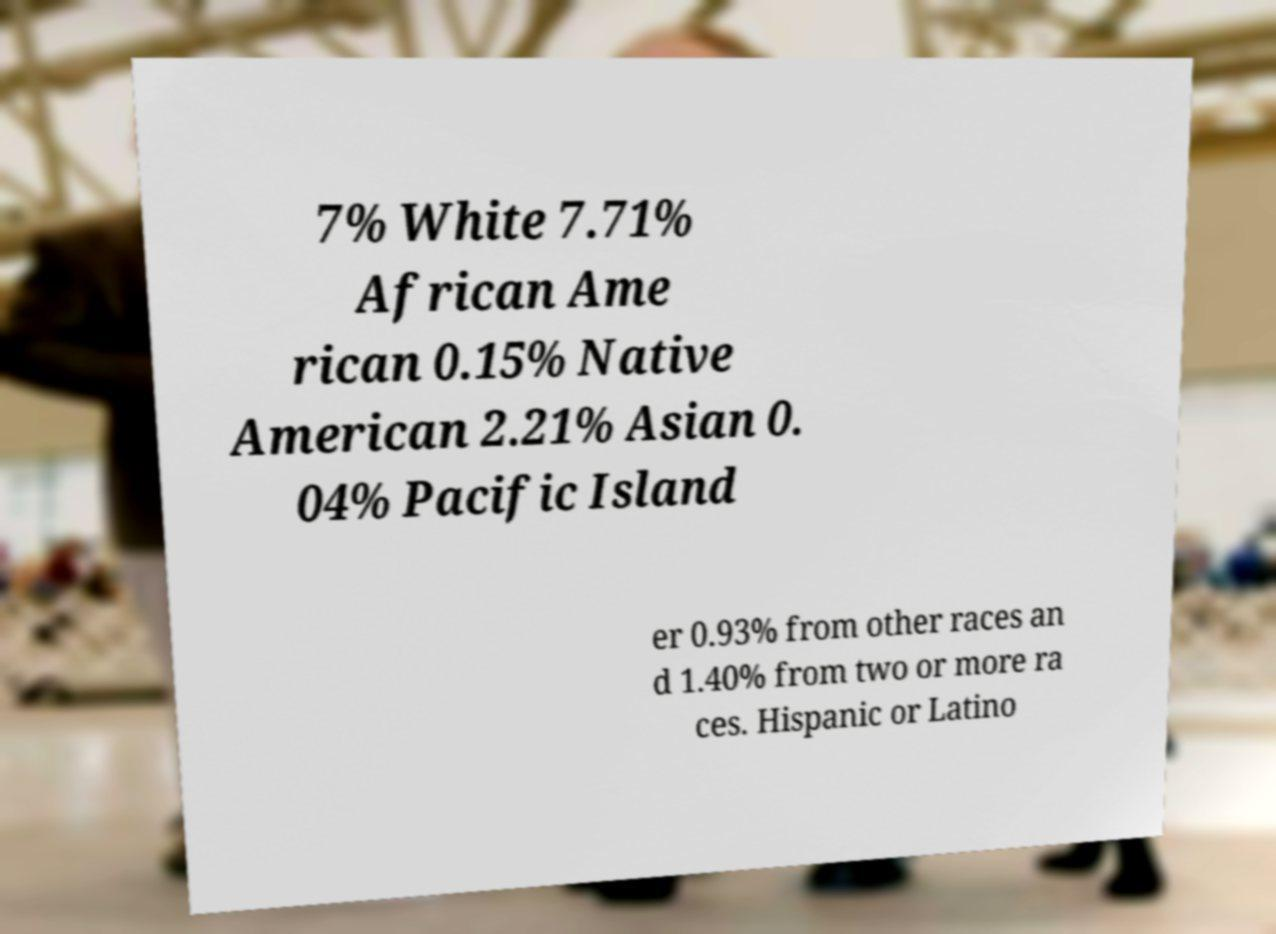Can you read and provide the text displayed in the image?This photo seems to have some interesting text. Can you extract and type it out for me? 7% White 7.71% African Ame rican 0.15% Native American 2.21% Asian 0. 04% Pacific Island er 0.93% from other races an d 1.40% from two or more ra ces. Hispanic or Latino 